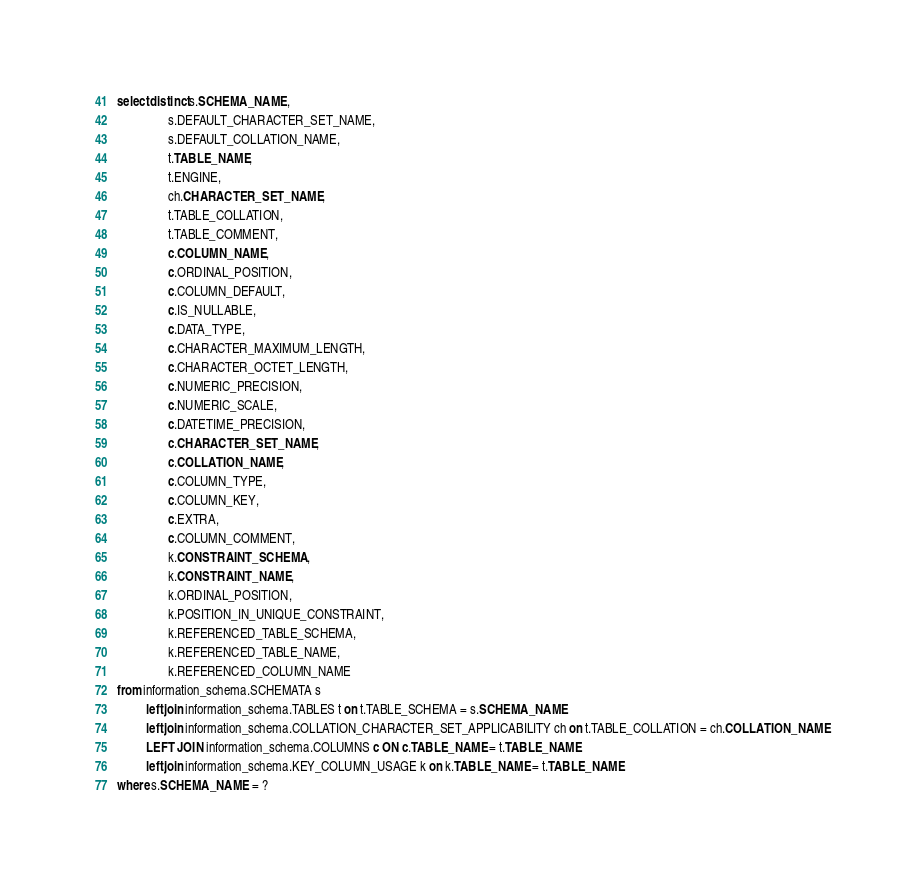<code> <loc_0><loc_0><loc_500><loc_500><_SQL_>select distinct s.SCHEMA_NAME,
                s.DEFAULT_CHARACTER_SET_NAME,
                s.DEFAULT_COLLATION_NAME,
                t.TABLE_NAME,
                t.ENGINE,
                ch.CHARACTER_SET_NAME,
                t.TABLE_COLLATION,
                t.TABLE_COMMENT,
                c.COLUMN_NAME,
                c.ORDINAL_POSITION,
                c.COLUMN_DEFAULT,
                c.IS_NULLABLE,
                c.DATA_TYPE,
                c.CHARACTER_MAXIMUM_LENGTH,
                c.CHARACTER_OCTET_LENGTH,
                c.NUMERIC_PRECISION,
                c.NUMERIC_SCALE,
                c.DATETIME_PRECISION,
                c.CHARACTER_SET_NAME,
                c.COLLATION_NAME,
                c.COLUMN_TYPE,
                c.COLUMN_KEY,
                c.EXTRA,
                c.COLUMN_COMMENT,
                k.CONSTRAINT_SCHEMA,
                k.CONSTRAINT_NAME,
                k.ORDINAL_POSITION,
                k.POSITION_IN_UNIQUE_CONSTRAINT,
                k.REFERENCED_TABLE_SCHEMA,
                k.REFERENCED_TABLE_NAME,
                k.REFERENCED_COLUMN_NAME
from information_schema.SCHEMATA s
         left join information_schema.TABLES t on t.TABLE_SCHEMA = s.SCHEMA_NAME
         left join information_schema.COLLATION_CHARACTER_SET_APPLICABILITY ch on t.TABLE_COLLATION = ch.COLLATION_NAME
         LEFT JOIN information_schema.COLUMNS c ON c.TABLE_NAME = t.TABLE_NAME
         left join information_schema.KEY_COLUMN_USAGE k on k.TABLE_NAME = t.TABLE_NAME
where s.SCHEMA_NAME = ?
</code> 